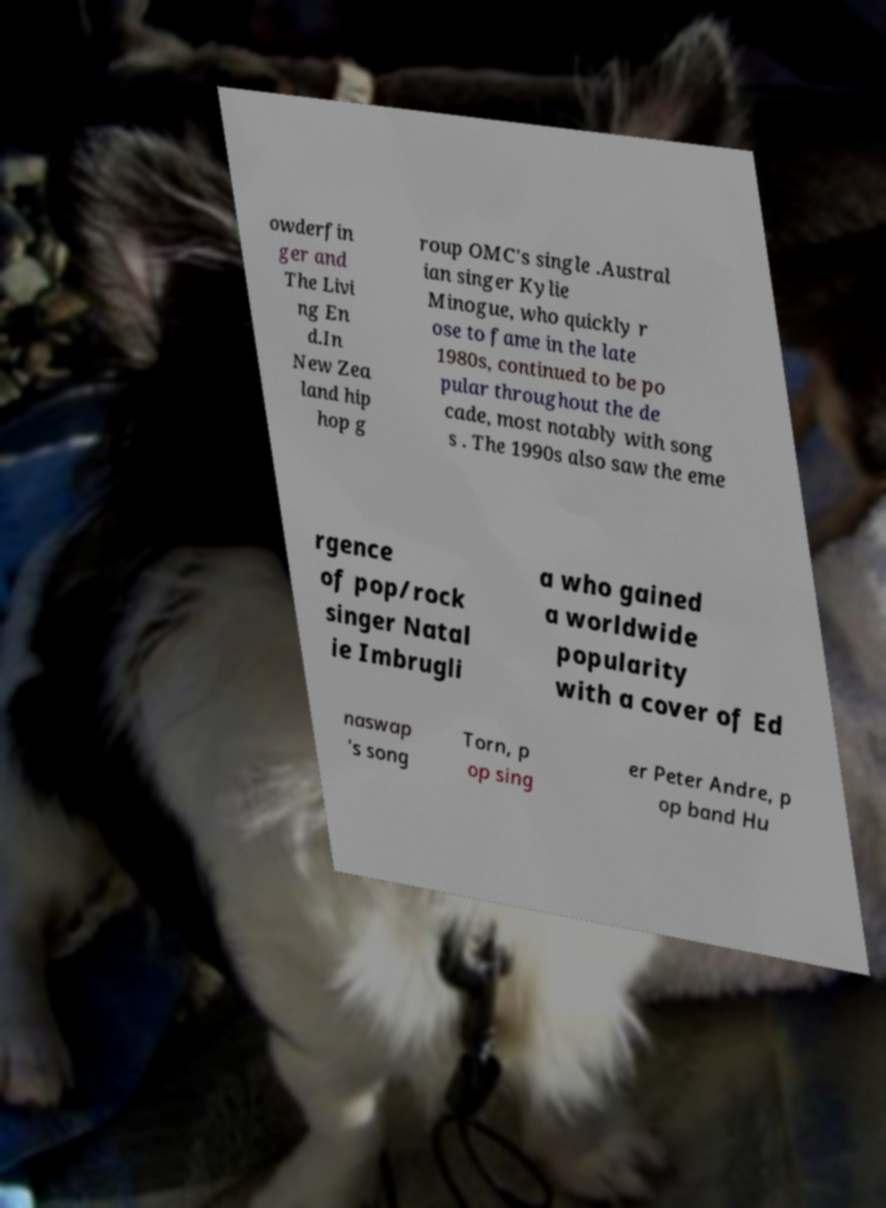Can you read and provide the text displayed in the image?This photo seems to have some interesting text. Can you extract and type it out for me? owderfin ger and The Livi ng En d.In New Zea land hip hop g roup OMC's single .Austral ian singer Kylie Minogue, who quickly r ose to fame in the late 1980s, continued to be po pular throughout the de cade, most notably with song s . The 1990s also saw the eme rgence of pop/rock singer Natal ie Imbrugli a who gained a worldwide popularity with a cover of Ed naswap 's song Torn, p op sing er Peter Andre, p op band Hu 